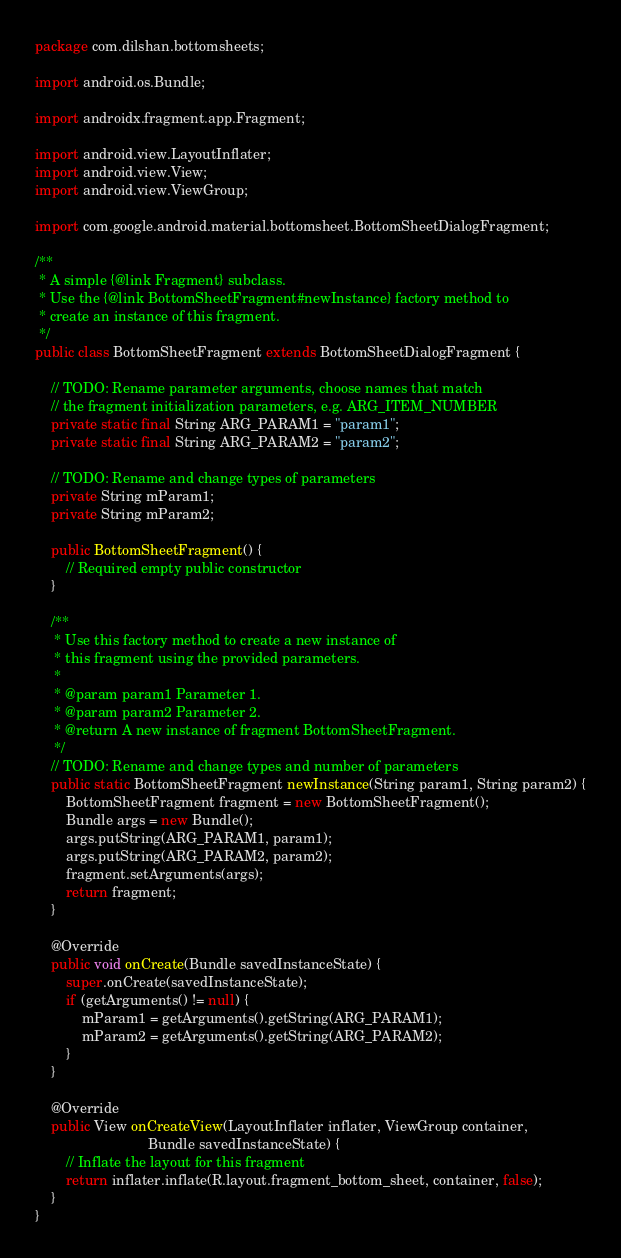<code> <loc_0><loc_0><loc_500><loc_500><_Java_>package com.dilshan.bottomsheets;

import android.os.Bundle;

import androidx.fragment.app.Fragment;

import android.view.LayoutInflater;
import android.view.View;
import android.view.ViewGroup;

import com.google.android.material.bottomsheet.BottomSheetDialogFragment;

/**
 * A simple {@link Fragment} subclass.
 * Use the {@link BottomSheetFragment#newInstance} factory method to
 * create an instance of this fragment.
 */
public class BottomSheetFragment extends BottomSheetDialogFragment {

    // TODO: Rename parameter arguments, choose names that match
    // the fragment initialization parameters, e.g. ARG_ITEM_NUMBER
    private static final String ARG_PARAM1 = "param1";
    private static final String ARG_PARAM2 = "param2";

    // TODO: Rename and change types of parameters
    private String mParam1;
    private String mParam2;

    public BottomSheetFragment() {
        // Required empty public constructor
    }

    /**
     * Use this factory method to create a new instance of
     * this fragment using the provided parameters.
     *
     * @param param1 Parameter 1.
     * @param param2 Parameter 2.
     * @return A new instance of fragment BottomSheetFragment.
     */
    // TODO: Rename and change types and number of parameters
    public static BottomSheetFragment newInstance(String param1, String param2) {
        BottomSheetFragment fragment = new BottomSheetFragment();
        Bundle args = new Bundle();
        args.putString(ARG_PARAM1, param1);
        args.putString(ARG_PARAM2, param2);
        fragment.setArguments(args);
        return fragment;
    }

    @Override
    public void onCreate(Bundle savedInstanceState) {
        super.onCreate(savedInstanceState);
        if (getArguments() != null) {
            mParam1 = getArguments().getString(ARG_PARAM1);
            mParam2 = getArguments().getString(ARG_PARAM2);
        }
    }

    @Override
    public View onCreateView(LayoutInflater inflater, ViewGroup container,
                             Bundle savedInstanceState) {
        // Inflate the layout for this fragment
        return inflater.inflate(R.layout.fragment_bottom_sheet, container, false);
    }
}</code> 